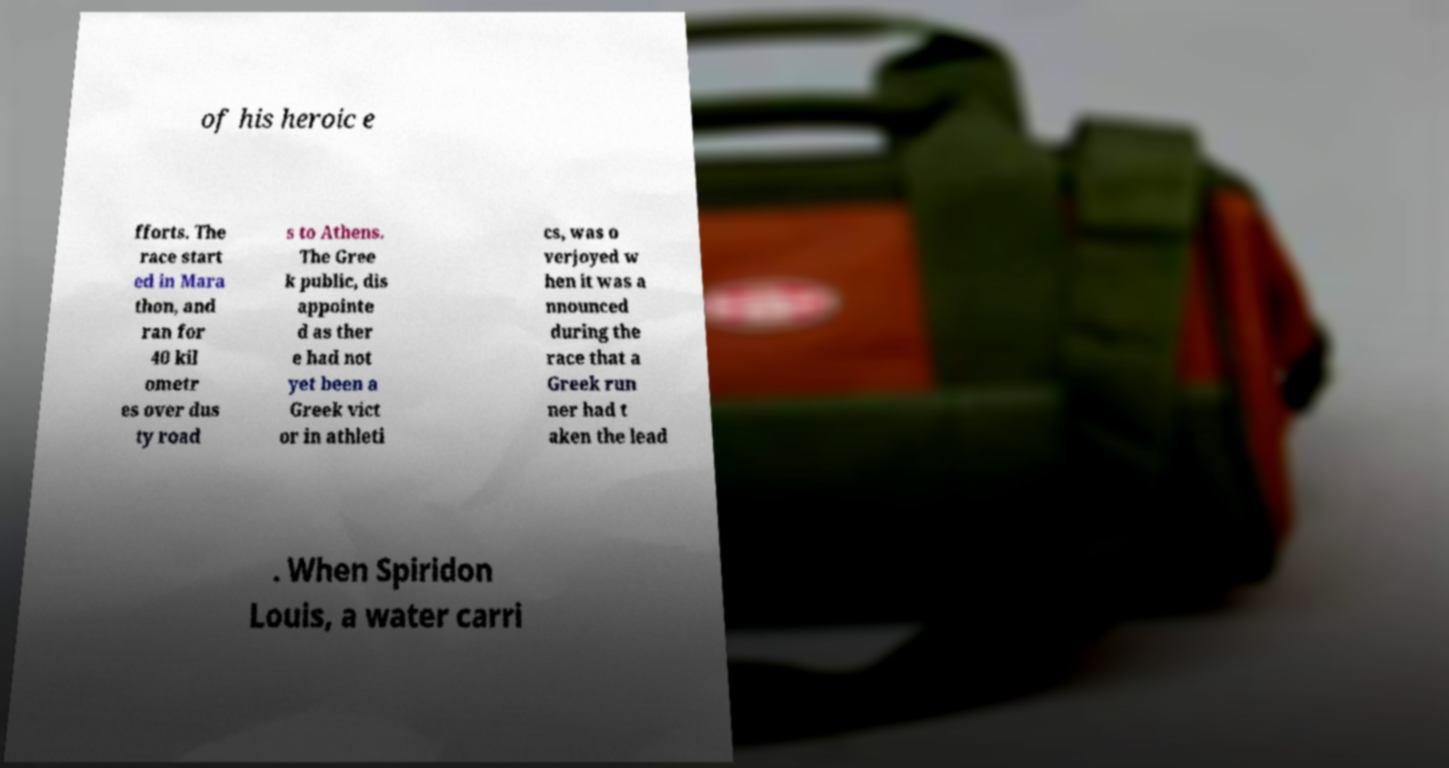For documentation purposes, I need the text within this image transcribed. Could you provide that? of his heroic e fforts. The race start ed in Mara thon, and ran for 40 kil ometr es over dus ty road s to Athens. The Gree k public, dis appointe d as ther e had not yet been a Greek vict or in athleti cs, was o verjoyed w hen it was a nnounced during the race that a Greek run ner had t aken the lead . When Spiridon Louis, a water carri 